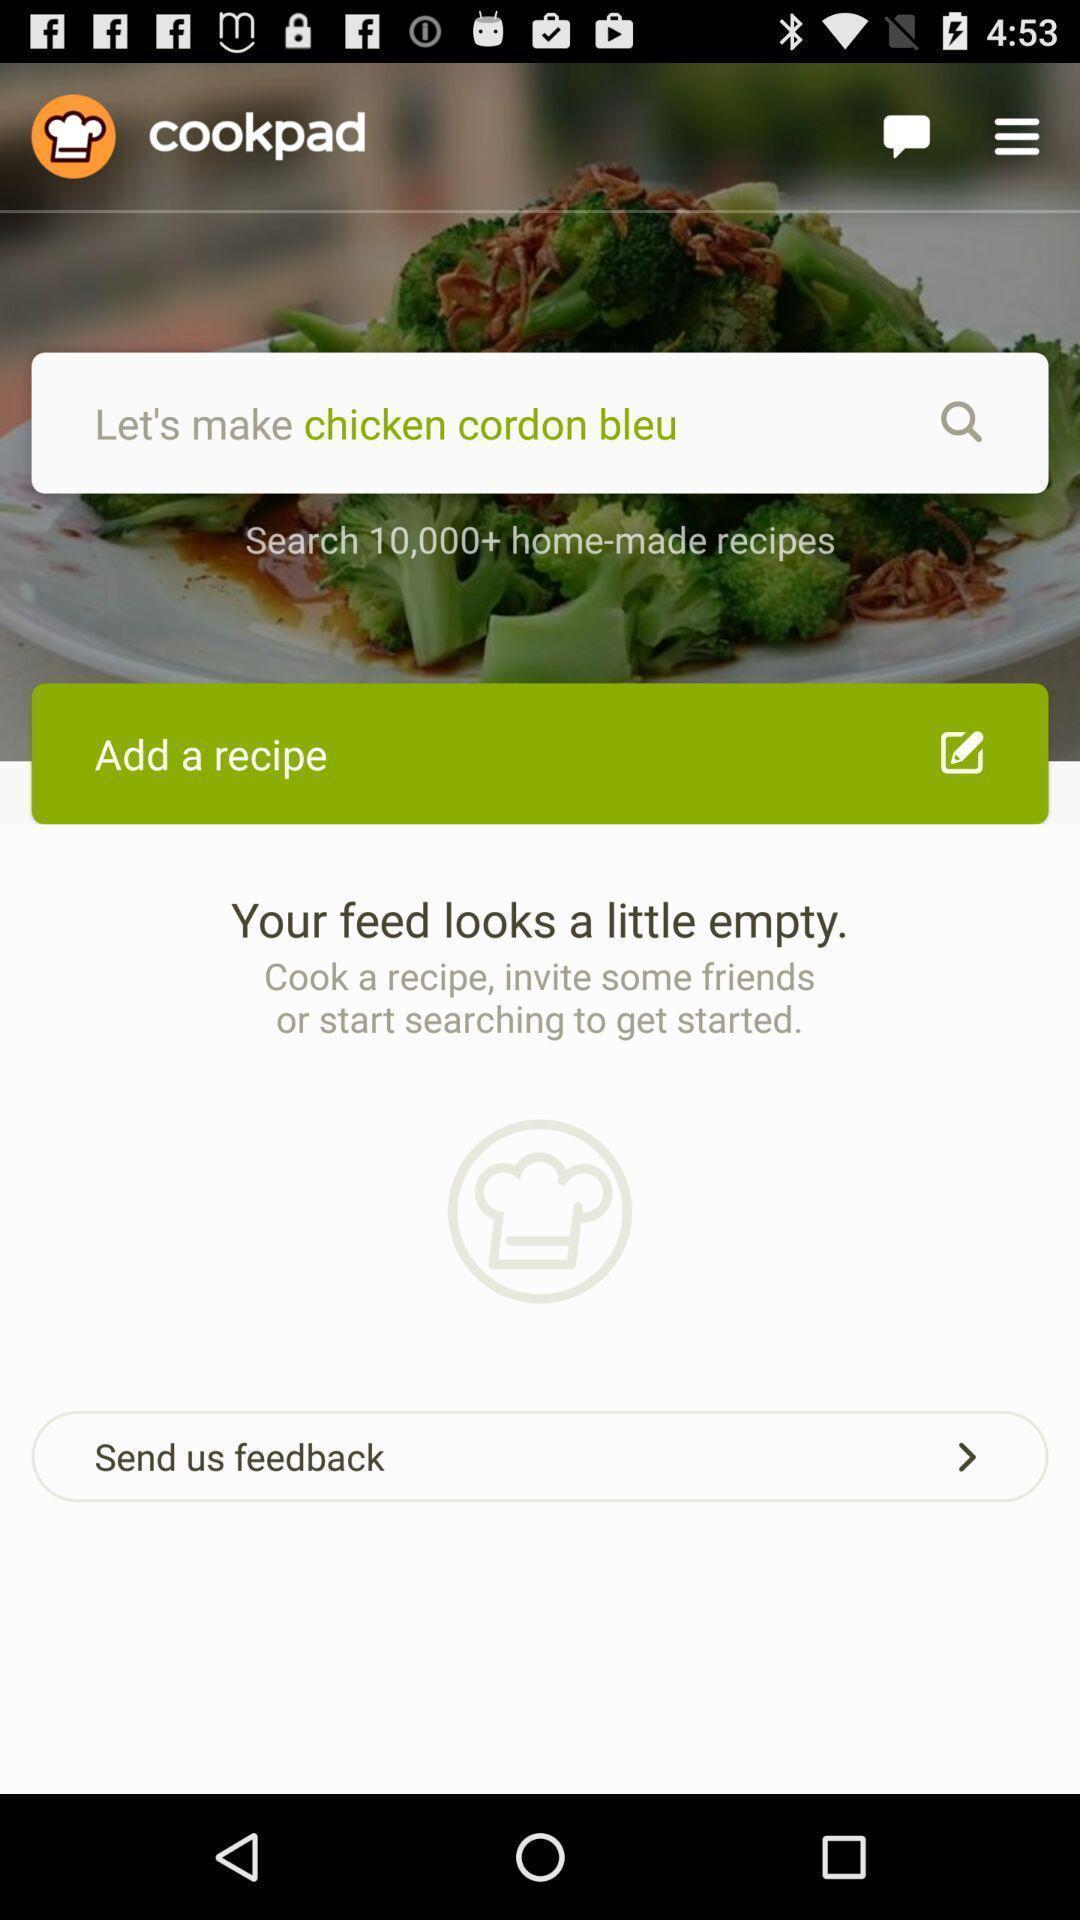What details can you identify in this image? Search page of food recipe application. 